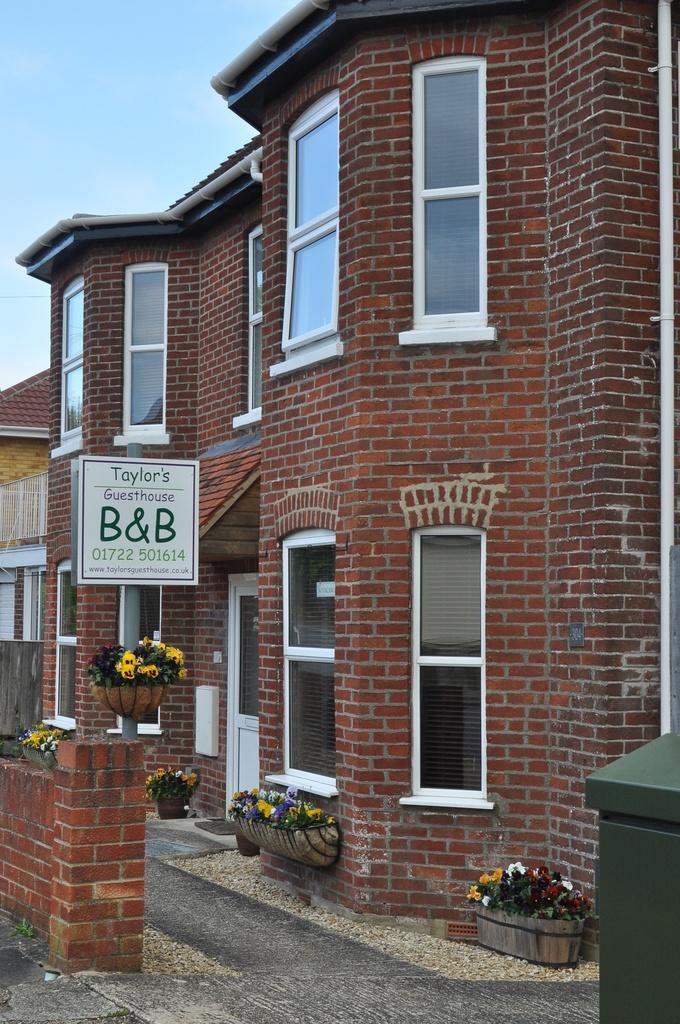Can you describe this image briefly? This picture is clicked outside. On the right we can see the flowers and the pots and we can see the building and the windows of the building and a red color brick wall of the building. In the background there is a sky. 